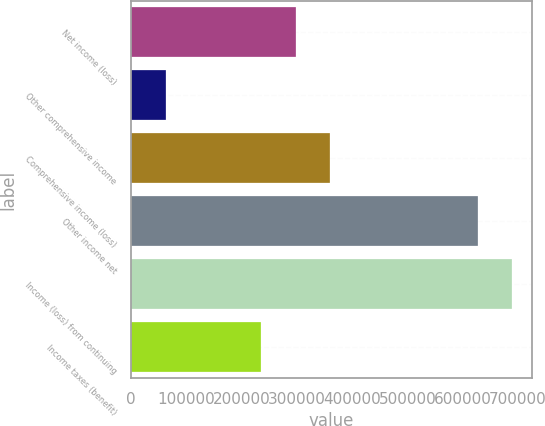Convert chart to OTSL. <chart><loc_0><loc_0><loc_500><loc_500><bar_chart><fcel>Net income (loss)<fcel>Other comprehensive income<fcel>Comprehensive income (loss)<fcel>Other income net<fcel>Income (loss) from continuing<fcel>Income taxes (benefit)<nl><fcel>297835<fcel>63591.1<fcel>360514<fcel>627703<fcel>690382<fcel>235156<nl></chart> 